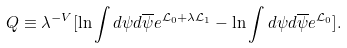<formula> <loc_0><loc_0><loc_500><loc_500>Q \equiv { \lambda } ^ { - V } { [ { \ln { \int { d \psi } { d \overline { \psi } } e ^ { { \mathcal { L } } _ { 0 } + { \lambda \mathcal { L } _ { 1 } } } } } - { \ln { \int { d \psi } { d \overline { \psi } } e ^ { { \mathcal { L } } _ { 0 } } } } ] } .</formula> 